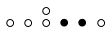Convert formula to latex. <formula><loc_0><loc_0><loc_500><loc_500>\begin{smallmatrix} & & \circ \\ \circ & \circ & \circ & \bullet & \bullet & \circ & \\ \end{smallmatrix}</formula> 